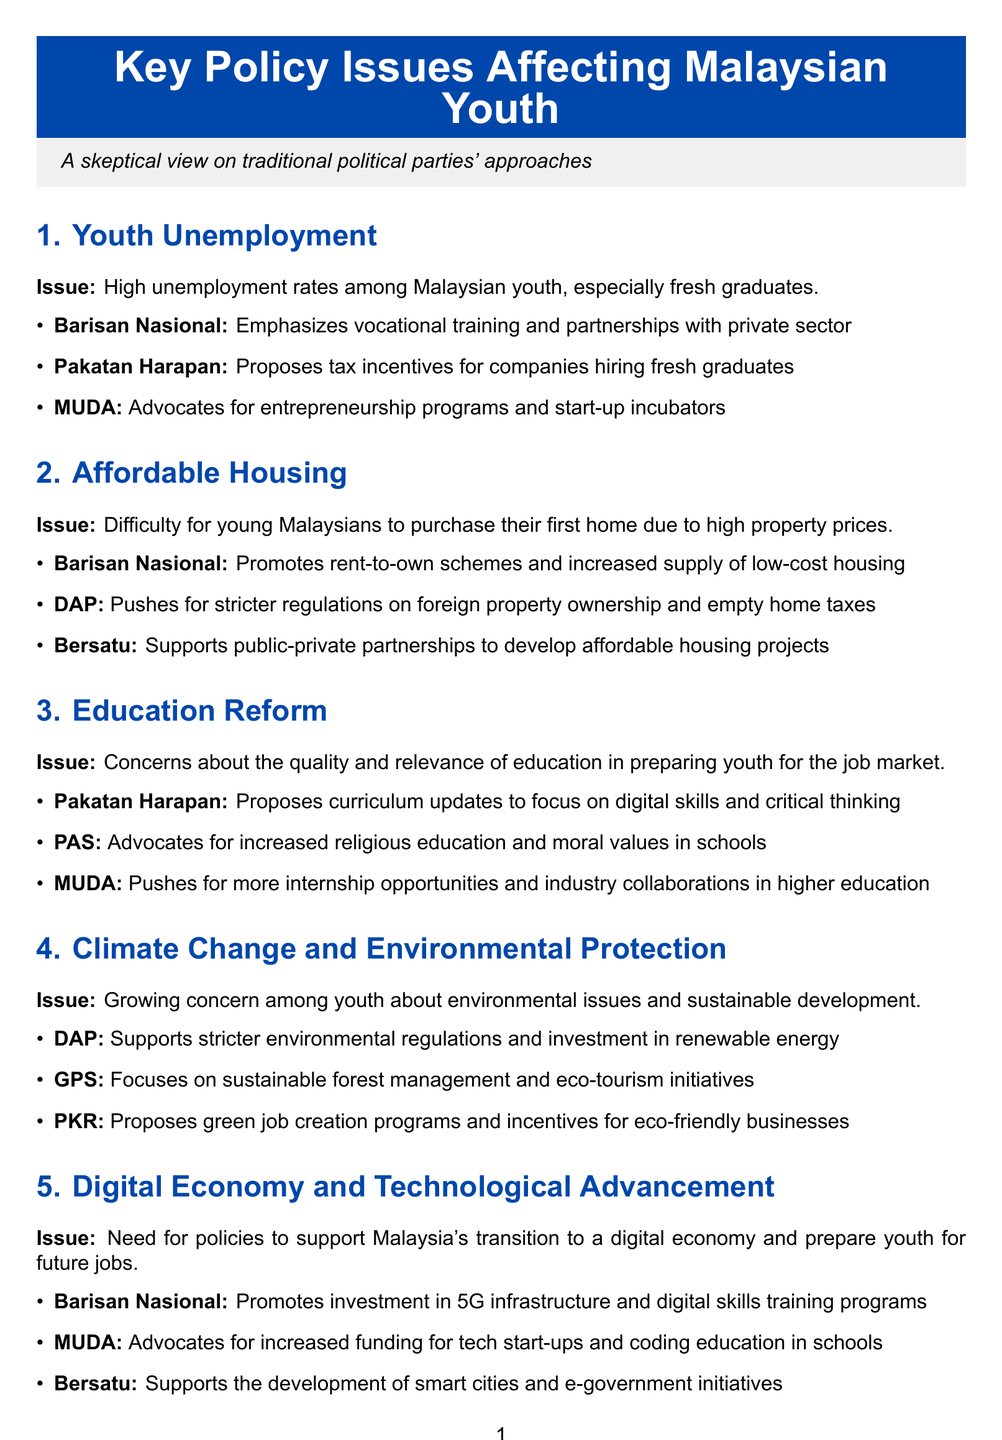What is the issue related to high unemployment? The document states that the issue is high unemployment rates among Malaysian youth, especially fresh graduates.
Answer: Youth unemployment Which political entity emphasizes vocational training? Barisan Nasional's approach includes emphasizing vocational training.
Answer: Barisan Nasional What does Pakatan Harapan propose for hiring fresh graduates? Pakatan Harapan proposes tax incentives for companies hiring fresh graduates.
Answer: Tax incentives What issue is identified regarding young Malaysians and housing? The issue is the difficulty for young Malaysians to purchase their first home due to high property prices.
Answer: Affordable housing What do MUDA and PKR advocate for in the context of political reform? MUDA pushes for youth representation in government and PKR advocates for separation of powers.
Answer: Youth representation; Separation of powers Which political entity supports renewable energy investment? The document indicates that DAP supports stricter environmental regulations and investment in renewable energy.
Answer: DAP What is Pakatan Harapan's proposed focus in education reform? Pakatan Harapan proposes curriculum updates to focus on digital skills and critical thinking.
Answer: Digital skills and critical thinking How many key policy issues are discussed in the document? The memo discusses six key policy issues affecting Malaysian youth.
Answer: Six What is Bersatu's approach to affordable housing? Bersatu supports public-private partnerships to develop affordable housing projects.
Answer: Public-private partnerships 